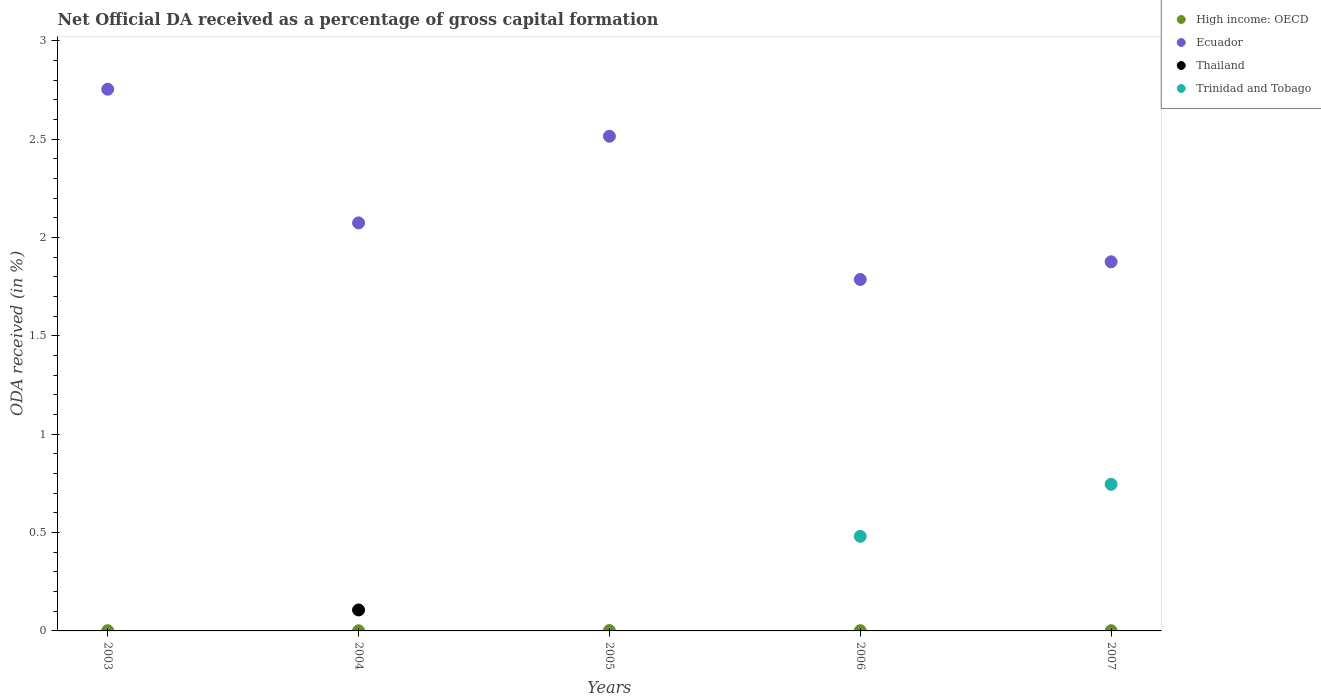Is the number of dotlines equal to the number of legend labels?
Provide a succinct answer. No. Across all years, what is the maximum net ODA received in Trinidad and Tobago?
Your answer should be very brief. 0.75. Across all years, what is the minimum net ODA received in Thailand?
Your answer should be very brief. 0. In which year was the net ODA received in Trinidad and Tobago maximum?
Provide a short and direct response. 2007. What is the total net ODA received in Trinidad and Tobago in the graph?
Keep it short and to the point. 1.23. What is the difference between the net ODA received in High income: OECD in 2005 and that in 2007?
Make the answer very short. 0. What is the difference between the net ODA received in Trinidad and Tobago in 2006 and the net ODA received in Thailand in 2003?
Make the answer very short. 0.48. What is the average net ODA received in Thailand per year?
Give a very brief answer. 0.02. In the year 2004, what is the difference between the net ODA received in Thailand and net ODA received in Ecuador?
Offer a very short reply. -1.97. What is the ratio of the net ODA received in High income: OECD in 2004 to that in 2007?
Give a very brief answer. 0.65. Is the net ODA received in Ecuador in 2005 less than that in 2006?
Offer a terse response. No. What is the difference between the highest and the second highest net ODA received in High income: OECD?
Ensure brevity in your answer.  0. What is the difference between the highest and the lowest net ODA received in Ecuador?
Offer a terse response. 0.97. In how many years, is the net ODA received in Thailand greater than the average net ODA received in Thailand taken over all years?
Your response must be concise. 1. Is it the case that in every year, the sum of the net ODA received in Ecuador and net ODA received in Thailand  is greater than the sum of net ODA received in Trinidad and Tobago and net ODA received in High income: OECD?
Your answer should be compact. No. Does the net ODA received in Trinidad and Tobago monotonically increase over the years?
Offer a very short reply. Yes. Is the net ODA received in Trinidad and Tobago strictly greater than the net ODA received in Ecuador over the years?
Keep it short and to the point. No. Is the net ODA received in Thailand strictly less than the net ODA received in Trinidad and Tobago over the years?
Keep it short and to the point. No. How many dotlines are there?
Ensure brevity in your answer.  4. Are the values on the major ticks of Y-axis written in scientific E-notation?
Make the answer very short. No. Where does the legend appear in the graph?
Your answer should be compact. Top right. What is the title of the graph?
Provide a succinct answer. Net Official DA received as a percentage of gross capital formation. What is the label or title of the Y-axis?
Offer a terse response. ODA received (in %). What is the ODA received (in %) of High income: OECD in 2003?
Give a very brief answer. 0. What is the ODA received (in %) of Ecuador in 2003?
Ensure brevity in your answer.  2.75. What is the ODA received (in %) in High income: OECD in 2004?
Make the answer very short. 0. What is the ODA received (in %) of Ecuador in 2004?
Ensure brevity in your answer.  2.07. What is the ODA received (in %) of Thailand in 2004?
Make the answer very short. 0.11. What is the ODA received (in %) of Trinidad and Tobago in 2004?
Provide a short and direct response. 0. What is the ODA received (in %) of High income: OECD in 2005?
Your response must be concise. 0. What is the ODA received (in %) of Ecuador in 2005?
Your response must be concise. 2.51. What is the ODA received (in %) in Thailand in 2005?
Offer a terse response. 0. What is the ODA received (in %) of High income: OECD in 2006?
Give a very brief answer. 0. What is the ODA received (in %) in Ecuador in 2006?
Your answer should be compact. 1.79. What is the ODA received (in %) in Trinidad and Tobago in 2006?
Ensure brevity in your answer.  0.48. What is the ODA received (in %) in High income: OECD in 2007?
Offer a terse response. 0. What is the ODA received (in %) of Ecuador in 2007?
Give a very brief answer. 1.88. What is the ODA received (in %) in Trinidad and Tobago in 2007?
Offer a terse response. 0.75. Across all years, what is the maximum ODA received (in %) of High income: OECD?
Keep it short and to the point. 0. Across all years, what is the maximum ODA received (in %) in Ecuador?
Make the answer very short. 2.75. Across all years, what is the maximum ODA received (in %) in Thailand?
Your response must be concise. 0.11. Across all years, what is the maximum ODA received (in %) of Trinidad and Tobago?
Keep it short and to the point. 0.75. Across all years, what is the minimum ODA received (in %) of High income: OECD?
Give a very brief answer. 0. Across all years, what is the minimum ODA received (in %) in Ecuador?
Offer a terse response. 1.79. Across all years, what is the minimum ODA received (in %) in Thailand?
Offer a terse response. 0. What is the total ODA received (in %) of High income: OECD in the graph?
Your response must be concise. 0.01. What is the total ODA received (in %) of Ecuador in the graph?
Give a very brief answer. 11. What is the total ODA received (in %) in Thailand in the graph?
Provide a short and direct response. 0.11. What is the total ODA received (in %) in Trinidad and Tobago in the graph?
Offer a very short reply. 1.23. What is the difference between the ODA received (in %) of High income: OECD in 2003 and that in 2004?
Offer a terse response. 0. What is the difference between the ODA received (in %) in Ecuador in 2003 and that in 2004?
Offer a very short reply. 0.68. What is the difference between the ODA received (in %) of High income: OECD in 2003 and that in 2005?
Give a very brief answer. -0. What is the difference between the ODA received (in %) in Ecuador in 2003 and that in 2005?
Your answer should be compact. 0.24. What is the difference between the ODA received (in %) of Ecuador in 2003 and that in 2006?
Ensure brevity in your answer.  0.97. What is the difference between the ODA received (in %) of High income: OECD in 2003 and that in 2007?
Make the answer very short. 0. What is the difference between the ODA received (in %) of Ecuador in 2003 and that in 2007?
Keep it short and to the point. 0.88. What is the difference between the ODA received (in %) in High income: OECD in 2004 and that in 2005?
Offer a very short reply. -0. What is the difference between the ODA received (in %) of Ecuador in 2004 and that in 2005?
Offer a very short reply. -0.44. What is the difference between the ODA received (in %) of High income: OECD in 2004 and that in 2006?
Make the answer very short. -0. What is the difference between the ODA received (in %) of Ecuador in 2004 and that in 2006?
Ensure brevity in your answer.  0.29. What is the difference between the ODA received (in %) of High income: OECD in 2004 and that in 2007?
Keep it short and to the point. -0. What is the difference between the ODA received (in %) of Ecuador in 2004 and that in 2007?
Provide a short and direct response. 0.2. What is the difference between the ODA received (in %) of High income: OECD in 2005 and that in 2006?
Your answer should be compact. 0. What is the difference between the ODA received (in %) in Ecuador in 2005 and that in 2006?
Offer a very short reply. 0.73. What is the difference between the ODA received (in %) in Ecuador in 2005 and that in 2007?
Ensure brevity in your answer.  0.64. What is the difference between the ODA received (in %) in Ecuador in 2006 and that in 2007?
Give a very brief answer. -0.09. What is the difference between the ODA received (in %) in Trinidad and Tobago in 2006 and that in 2007?
Your answer should be compact. -0.26. What is the difference between the ODA received (in %) in High income: OECD in 2003 and the ODA received (in %) in Ecuador in 2004?
Ensure brevity in your answer.  -2.07. What is the difference between the ODA received (in %) of High income: OECD in 2003 and the ODA received (in %) of Thailand in 2004?
Offer a very short reply. -0.11. What is the difference between the ODA received (in %) of Ecuador in 2003 and the ODA received (in %) of Thailand in 2004?
Provide a succinct answer. 2.65. What is the difference between the ODA received (in %) in High income: OECD in 2003 and the ODA received (in %) in Ecuador in 2005?
Your answer should be very brief. -2.51. What is the difference between the ODA received (in %) of High income: OECD in 2003 and the ODA received (in %) of Ecuador in 2006?
Make the answer very short. -1.78. What is the difference between the ODA received (in %) in High income: OECD in 2003 and the ODA received (in %) in Trinidad and Tobago in 2006?
Keep it short and to the point. -0.48. What is the difference between the ODA received (in %) in Ecuador in 2003 and the ODA received (in %) in Trinidad and Tobago in 2006?
Offer a very short reply. 2.27. What is the difference between the ODA received (in %) in High income: OECD in 2003 and the ODA received (in %) in Ecuador in 2007?
Keep it short and to the point. -1.87. What is the difference between the ODA received (in %) of High income: OECD in 2003 and the ODA received (in %) of Trinidad and Tobago in 2007?
Your response must be concise. -0.74. What is the difference between the ODA received (in %) in Ecuador in 2003 and the ODA received (in %) in Trinidad and Tobago in 2007?
Provide a short and direct response. 2.01. What is the difference between the ODA received (in %) in High income: OECD in 2004 and the ODA received (in %) in Ecuador in 2005?
Your response must be concise. -2.51. What is the difference between the ODA received (in %) in High income: OECD in 2004 and the ODA received (in %) in Ecuador in 2006?
Give a very brief answer. -1.79. What is the difference between the ODA received (in %) of High income: OECD in 2004 and the ODA received (in %) of Trinidad and Tobago in 2006?
Offer a terse response. -0.48. What is the difference between the ODA received (in %) in Ecuador in 2004 and the ODA received (in %) in Trinidad and Tobago in 2006?
Your answer should be compact. 1.59. What is the difference between the ODA received (in %) in Thailand in 2004 and the ODA received (in %) in Trinidad and Tobago in 2006?
Ensure brevity in your answer.  -0.37. What is the difference between the ODA received (in %) in High income: OECD in 2004 and the ODA received (in %) in Ecuador in 2007?
Offer a very short reply. -1.88. What is the difference between the ODA received (in %) in High income: OECD in 2004 and the ODA received (in %) in Trinidad and Tobago in 2007?
Keep it short and to the point. -0.74. What is the difference between the ODA received (in %) of Ecuador in 2004 and the ODA received (in %) of Trinidad and Tobago in 2007?
Ensure brevity in your answer.  1.33. What is the difference between the ODA received (in %) in Thailand in 2004 and the ODA received (in %) in Trinidad and Tobago in 2007?
Your response must be concise. -0.64. What is the difference between the ODA received (in %) of High income: OECD in 2005 and the ODA received (in %) of Ecuador in 2006?
Provide a short and direct response. -1.78. What is the difference between the ODA received (in %) in High income: OECD in 2005 and the ODA received (in %) in Trinidad and Tobago in 2006?
Provide a succinct answer. -0.48. What is the difference between the ODA received (in %) of Ecuador in 2005 and the ODA received (in %) of Trinidad and Tobago in 2006?
Make the answer very short. 2.03. What is the difference between the ODA received (in %) of High income: OECD in 2005 and the ODA received (in %) of Ecuador in 2007?
Provide a short and direct response. -1.87. What is the difference between the ODA received (in %) of High income: OECD in 2005 and the ODA received (in %) of Trinidad and Tobago in 2007?
Your answer should be compact. -0.74. What is the difference between the ODA received (in %) of Ecuador in 2005 and the ODA received (in %) of Trinidad and Tobago in 2007?
Provide a succinct answer. 1.77. What is the difference between the ODA received (in %) in High income: OECD in 2006 and the ODA received (in %) in Ecuador in 2007?
Offer a very short reply. -1.88. What is the difference between the ODA received (in %) in High income: OECD in 2006 and the ODA received (in %) in Trinidad and Tobago in 2007?
Provide a succinct answer. -0.74. What is the difference between the ODA received (in %) of Ecuador in 2006 and the ODA received (in %) of Trinidad and Tobago in 2007?
Ensure brevity in your answer.  1.04. What is the average ODA received (in %) in High income: OECD per year?
Provide a short and direct response. 0. What is the average ODA received (in %) of Ecuador per year?
Offer a terse response. 2.2. What is the average ODA received (in %) in Thailand per year?
Make the answer very short. 0.02. What is the average ODA received (in %) in Trinidad and Tobago per year?
Offer a very short reply. 0.25. In the year 2003, what is the difference between the ODA received (in %) of High income: OECD and ODA received (in %) of Ecuador?
Make the answer very short. -2.75. In the year 2004, what is the difference between the ODA received (in %) of High income: OECD and ODA received (in %) of Ecuador?
Provide a succinct answer. -2.07. In the year 2004, what is the difference between the ODA received (in %) of High income: OECD and ODA received (in %) of Thailand?
Give a very brief answer. -0.11. In the year 2004, what is the difference between the ODA received (in %) in Ecuador and ODA received (in %) in Thailand?
Your response must be concise. 1.97. In the year 2005, what is the difference between the ODA received (in %) in High income: OECD and ODA received (in %) in Ecuador?
Your response must be concise. -2.51. In the year 2006, what is the difference between the ODA received (in %) in High income: OECD and ODA received (in %) in Ecuador?
Provide a short and direct response. -1.79. In the year 2006, what is the difference between the ODA received (in %) of High income: OECD and ODA received (in %) of Trinidad and Tobago?
Offer a very short reply. -0.48. In the year 2006, what is the difference between the ODA received (in %) in Ecuador and ODA received (in %) in Trinidad and Tobago?
Offer a very short reply. 1.31. In the year 2007, what is the difference between the ODA received (in %) of High income: OECD and ODA received (in %) of Ecuador?
Make the answer very short. -1.88. In the year 2007, what is the difference between the ODA received (in %) in High income: OECD and ODA received (in %) in Trinidad and Tobago?
Your answer should be very brief. -0.74. In the year 2007, what is the difference between the ODA received (in %) of Ecuador and ODA received (in %) of Trinidad and Tobago?
Offer a terse response. 1.13. What is the ratio of the ODA received (in %) in High income: OECD in 2003 to that in 2004?
Offer a terse response. 1.79. What is the ratio of the ODA received (in %) of Ecuador in 2003 to that in 2004?
Make the answer very short. 1.33. What is the ratio of the ODA received (in %) in High income: OECD in 2003 to that in 2005?
Your answer should be compact. 0.62. What is the ratio of the ODA received (in %) of Ecuador in 2003 to that in 2005?
Provide a succinct answer. 1.09. What is the ratio of the ODA received (in %) in High income: OECD in 2003 to that in 2006?
Your answer should be compact. 1.11. What is the ratio of the ODA received (in %) in Ecuador in 2003 to that in 2006?
Your answer should be compact. 1.54. What is the ratio of the ODA received (in %) in High income: OECD in 2003 to that in 2007?
Ensure brevity in your answer.  1.17. What is the ratio of the ODA received (in %) of Ecuador in 2003 to that in 2007?
Ensure brevity in your answer.  1.47. What is the ratio of the ODA received (in %) of High income: OECD in 2004 to that in 2005?
Give a very brief answer. 0.35. What is the ratio of the ODA received (in %) of Ecuador in 2004 to that in 2005?
Ensure brevity in your answer.  0.82. What is the ratio of the ODA received (in %) in High income: OECD in 2004 to that in 2006?
Your answer should be compact. 0.62. What is the ratio of the ODA received (in %) of Ecuador in 2004 to that in 2006?
Keep it short and to the point. 1.16. What is the ratio of the ODA received (in %) of High income: OECD in 2004 to that in 2007?
Ensure brevity in your answer.  0.65. What is the ratio of the ODA received (in %) of Ecuador in 2004 to that in 2007?
Offer a terse response. 1.11. What is the ratio of the ODA received (in %) in High income: OECD in 2005 to that in 2006?
Your answer should be compact. 1.77. What is the ratio of the ODA received (in %) in Ecuador in 2005 to that in 2006?
Your answer should be compact. 1.41. What is the ratio of the ODA received (in %) of High income: OECD in 2005 to that in 2007?
Your answer should be compact. 1.87. What is the ratio of the ODA received (in %) in Ecuador in 2005 to that in 2007?
Ensure brevity in your answer.  1.34. What is the ratio of the ODA received (in %) of High income: OECD in 2006 to that in 2007?
Provide a short and direct response. 1.06. What is the ratio of the ODA received (in %) of Ecuador in 2006 to that in 2007?
Give a very brief answer. 0.95. What is the ratio of the ODA received (in %) in Trinidad and Tobago in 2006 to that in 2007?
Offer a terse response. 0.65. What is the difference between the highest and the second highest ODA received (in %) of High income: OECD?
Offer a terse response. 0. What is the difference between the highest and the second highest ODA received (in %) of Ecuador?
Your answer should be very brief. 0.24. What is the difference between the highest and the lowest ODA received (in %) of High income: OECD?
Your response must be concise. 0. What is the difference between the highest and the lowest ODA received (in %) of Ecuador?
Keep it short and to the point. 0.97. What is the difference between the highest and the lowest ODA received (in %) in Thailand?
Give a very brief answer. 0.11. What is the difference between the highest and the lowest ODA received (in %) of Trinidad and Tobago?
Offer a terse response. 0.75. 